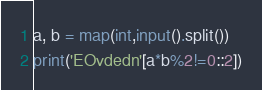<code> <loc_0><loc_0><loc_500><loc_500><_Python_>a, b = map(int,input().split())
print('EOvdedn'[a*b%2!=0::2])</code> 